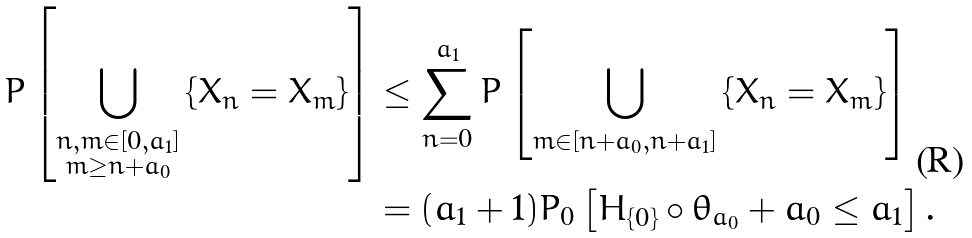<formula> <loc_0><loc_0><loc_500><loc_500>P \left [ \bigcup _ { \substack { n , m \in [ 0 , a _ { 1 } ] \\ m \geq n + a _ { 0 } } } \left \{ X _ { n } = X _ { m } \right \} \right ] & \leq \sum _ { n = 0 } ^ { a _ { 1 } } P \left [ \bigcup _ { m \in [ n + a _ { 0 } , n + a _ { 1 } ] } \left \{ X _ { n } = X _ { m } \right \} \right ] \\ & = ( a _ { 1 } + 1 ) P _ { 0 } \left [ H _ { \{ 0 \} } \circ \theta _ { a _ { 0 } } + a _ { 0 } \leq a _ { 1 } \right ] .</formula> 